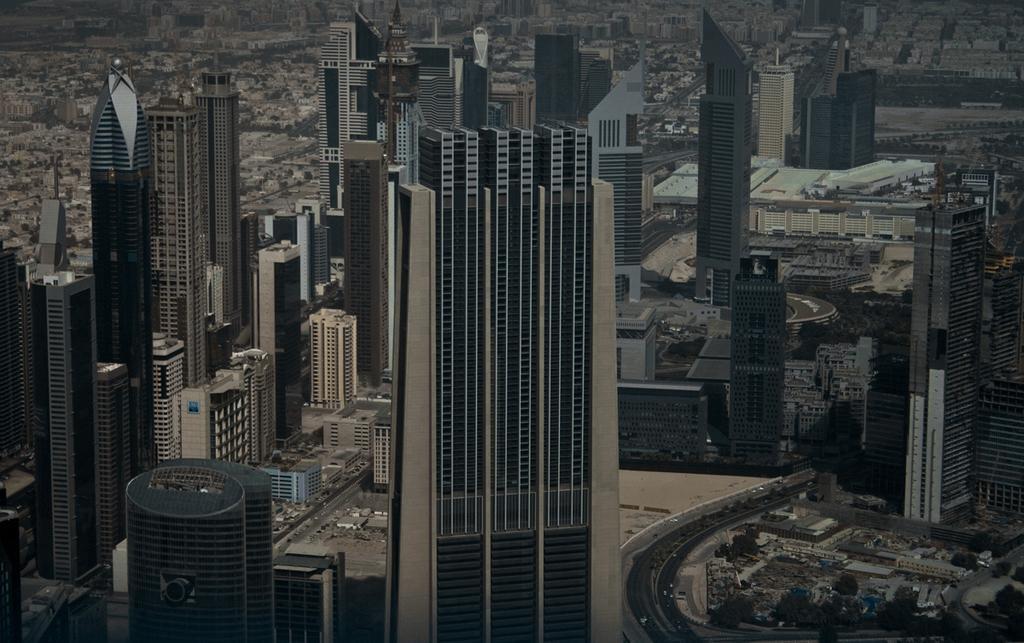Describe this image in one or two sentences. This is the top view image of a city, in this image there are buildings, roads and cars. 